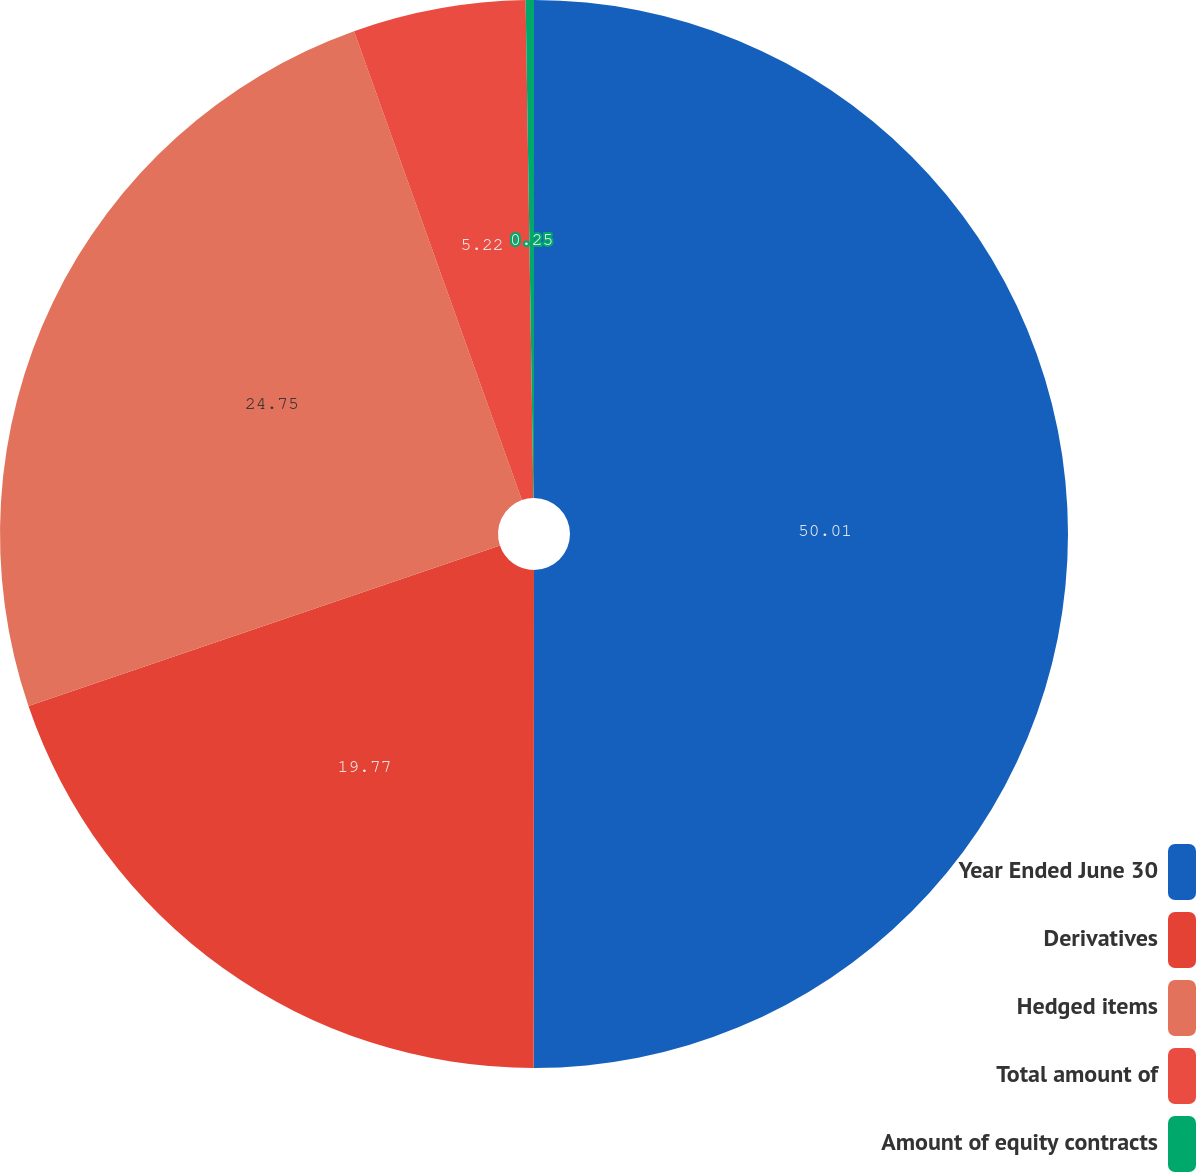Convert chart to OTSL. <chart><loc_0><loc_0><loc_500><loc_500><pie_chart><fcel>Year Ended June 30<fcel>Derivatives<fcel>Hedged items<fcel>Total amount of<fcel>Amount of equity contracts<nl><fcel>50.01%<fcel>19.77%<fcel>24.75%<fcel>5.22%<fcel>0.25%<nl></chart> 